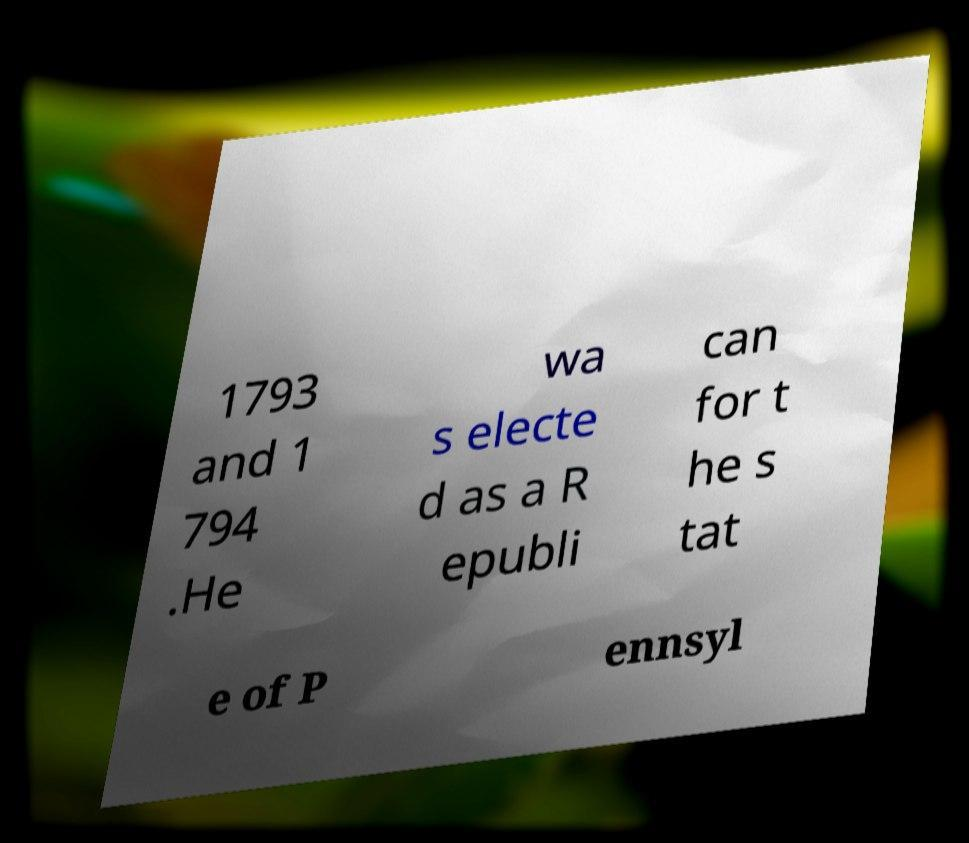Could you extract and type out the text from this image? 1793 and 1 794 .He wa s electe d as a R epubli can for t he s tat e of P ennsyl 